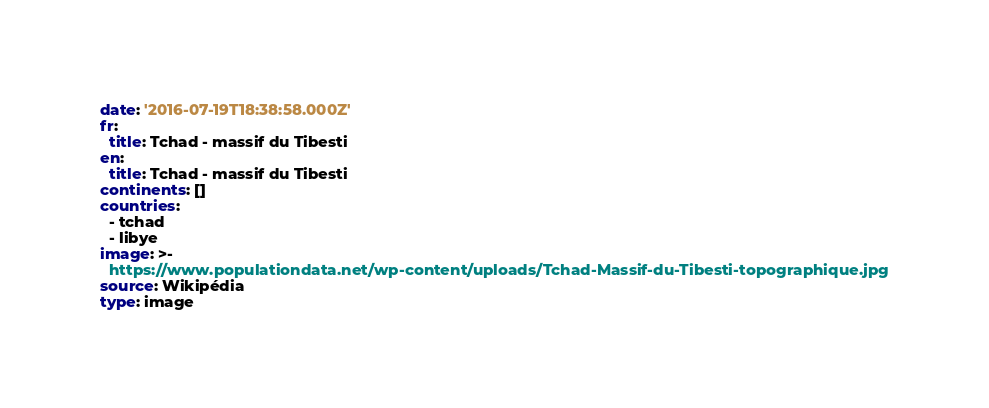Convert code to text. <code><loc_0><loc_0><loc_500><loc_500><_YAML_>date: '2016-07-19T18:38:58.000Z'
fr:
  title: Tchad - massif du Tibesti
en:
  title: Tchad - massif du Tibesti
continents: []
countries:
  - tchad
  - libye
image: >-
  https://www.populationdata.net/wp-content/uploads/Tchad-Massif-du-Tibesti-topographique.jpg
source: Wikipédia
type: image
</code> 